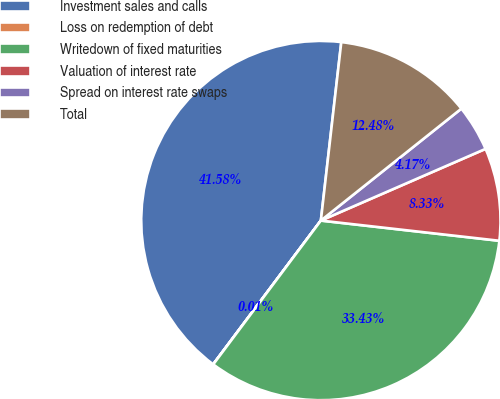<chart> <loc_0><loc_0><loc_500><loc_500><pie_chart><fcel>Investment sales and calls<fcel>Loss on redemption of debt<fcel>Writedown of fixed maturities<fcel>Valuation of interest rate<fcel>Spread on interest rate swaps<fcel>Total<nl><fcel>41.58%<fcel>0.01%<fcel>33.43%<fcel>8.33%<fcel>4.17%<fcel>12.48%<nl></chart> 